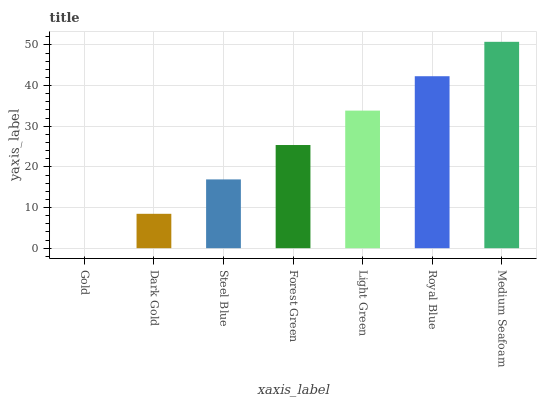Is Gold the minimum?
Answer yes or no. Yes. Is Medium Seafoam the maximum?
Answer yes or no. Yes. Is Dark Gold the minimum?
Answer yes or no. No. Is Dark Gold the maximum?
Answer yes or no. No. Is Dark Gold greater than Gold?
Answer yes or no. Yes. Is Gold less than Dark Gold?
Answer yes or no. Yes. Is Gold greater than Dark Gold?
Answer yes or no. No. Is Dark Gold less than Gold?
Answer yes or no. No. Is Forest Green the high median?
Answer yes or no. Yes. Is Forest Green the low median?
Answer yes or no. Yes. Is Medium Seafoam the high median?
Answer yes or no. No. Is Gold the low median?
Answer yes or no. No. 